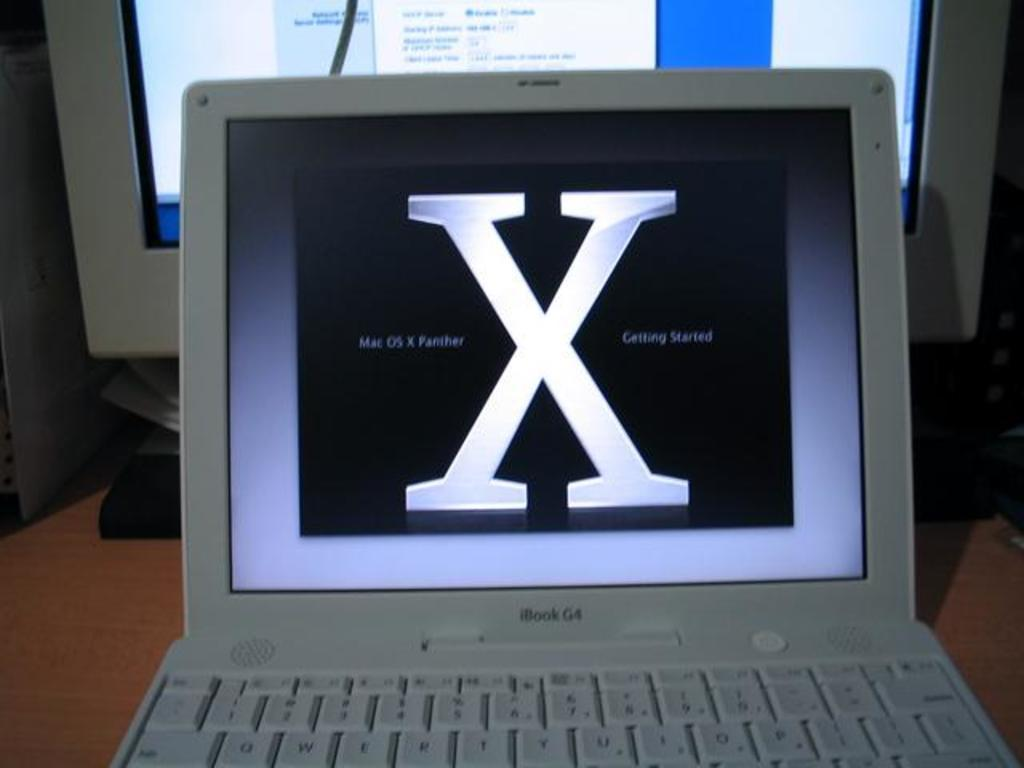<image>
Create a compact narrative representing the image presented. ibook laptop computer in white sits open on the desk 